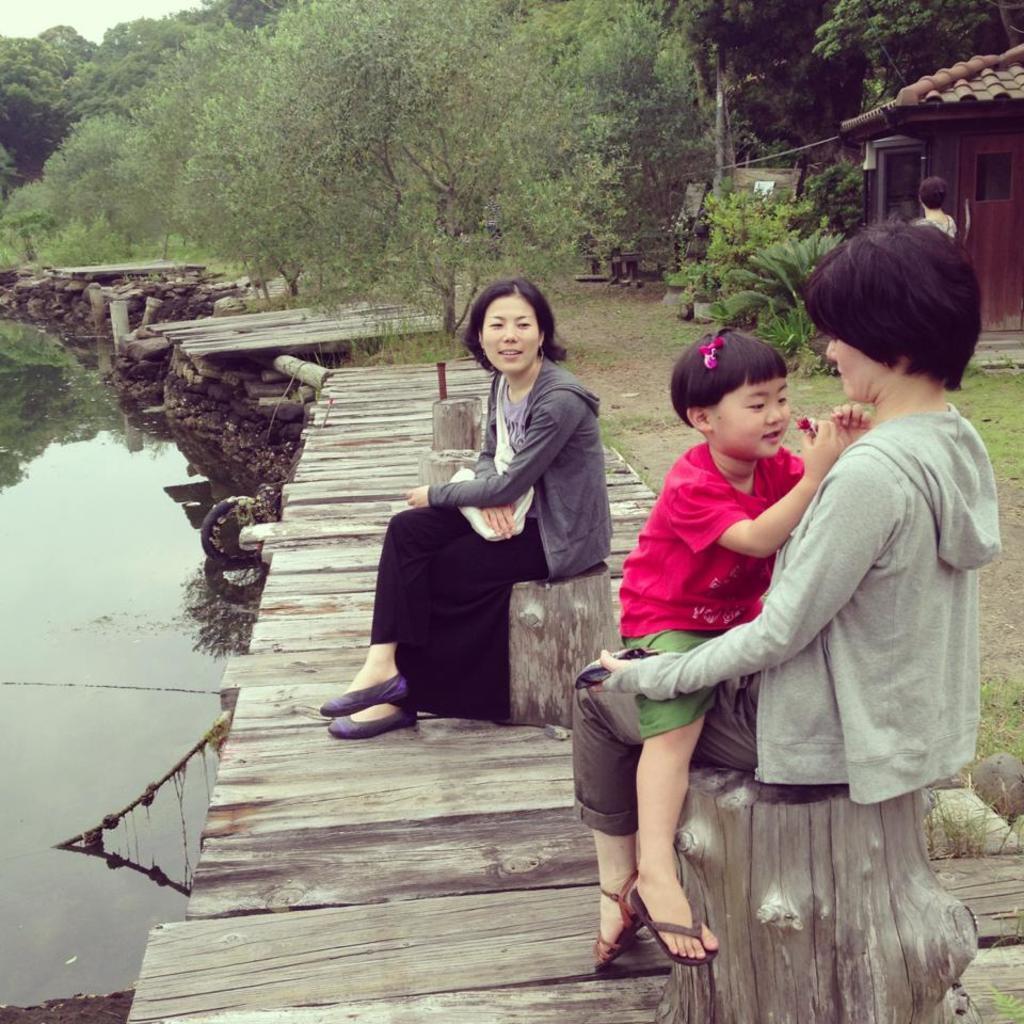How would you summarize this image in a sentence or two? In this image on the right side we can see a girl is sitting and woman, who is also sitting on a truck on the wooden platform and we can see another woman is also sitting on the trunk. In the background we can see water on the left side, trees, plants, a person and a house on the right side, doors and clouds in the sky. 